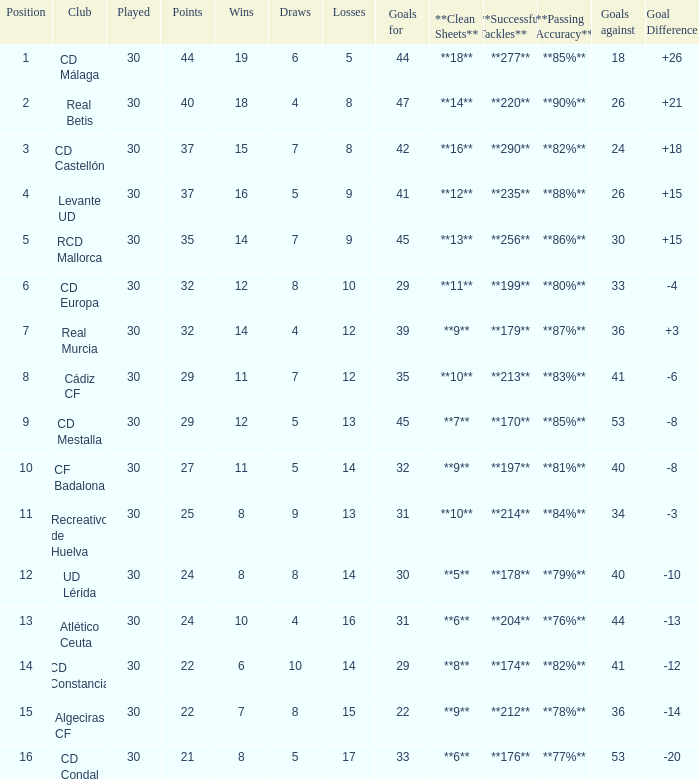What is the number of losses when the goal difference was -8, and position is smaller than 10? 1.0. 